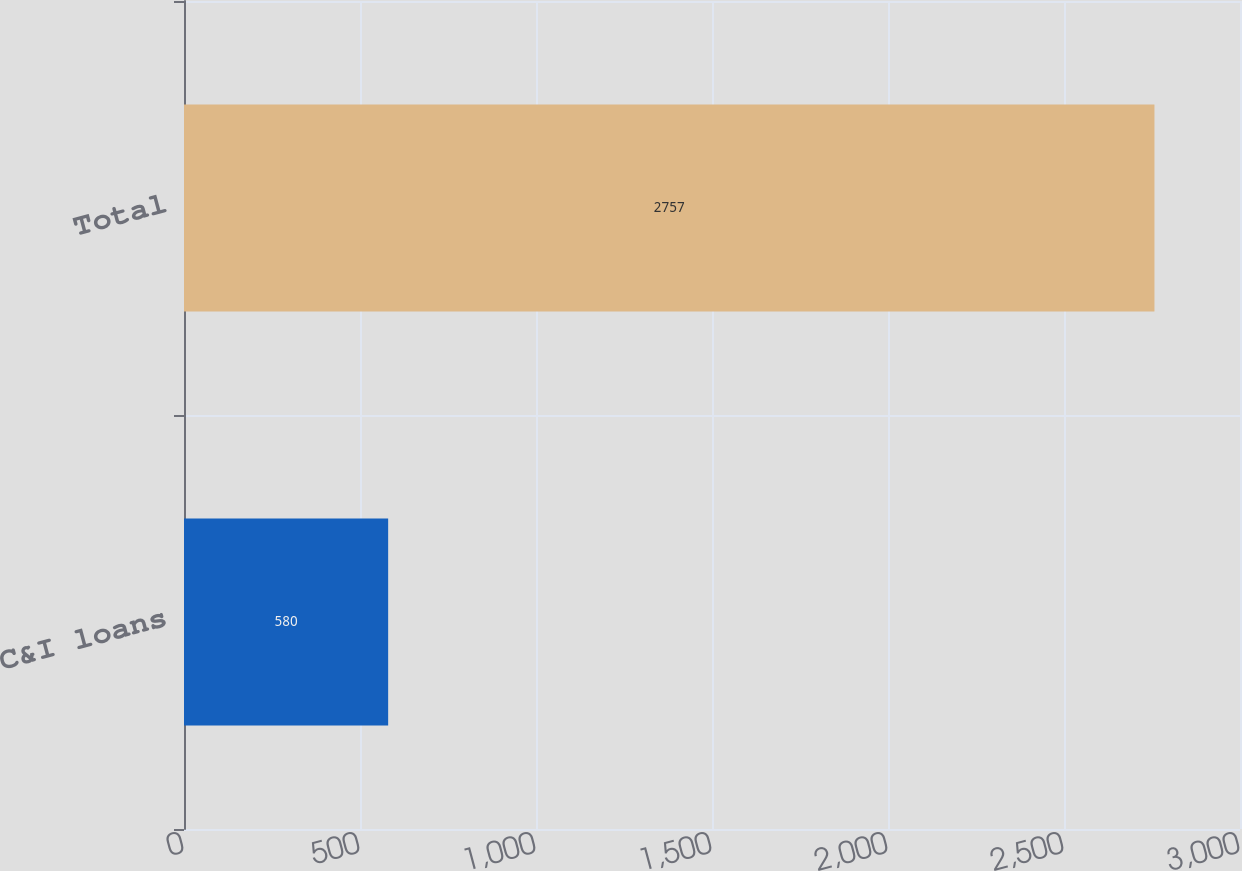Convert chart to OTSL. <chart><loc_0><loc_0><loc_500><loc_500><bar_chart><fcel>C&I loans<fcel>Total<nl><fcel>580<fcel>2757<nl></chart> 